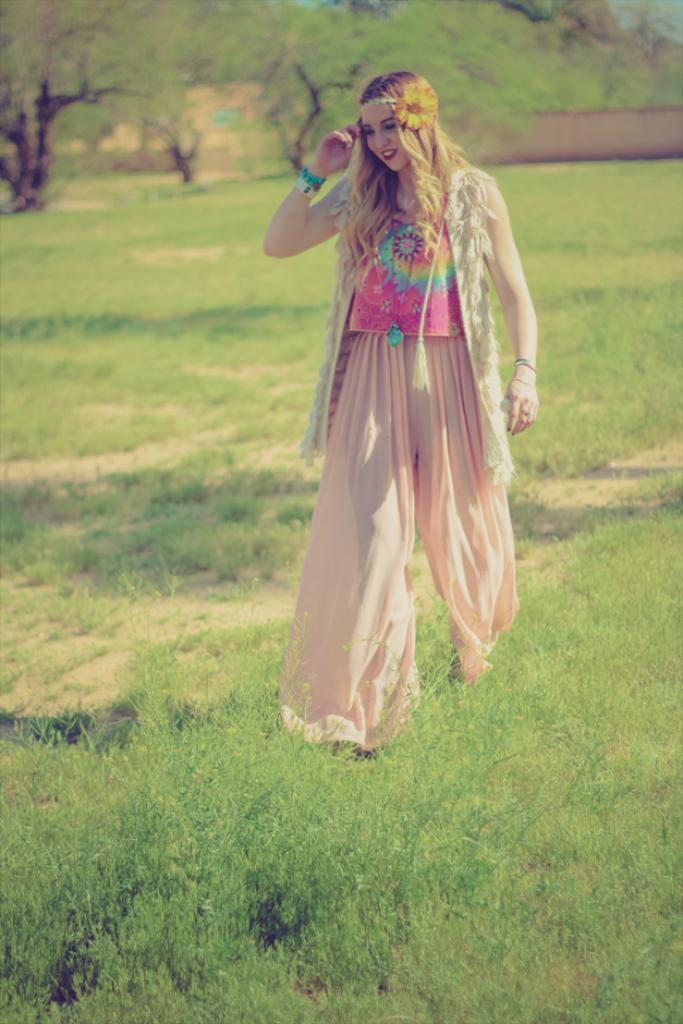Who is present in the image? There is a woman in the image. What is the woman standing on? The woman is standing on the grass. What can be seen in the background of the image? Walls, the sky, trees, and the ground are visible in the background of the image. Where is the throne located in the image? There is no throne present in the image. What type of hill can be seen in the background of the image? There is no hill visible in the background of the image. 